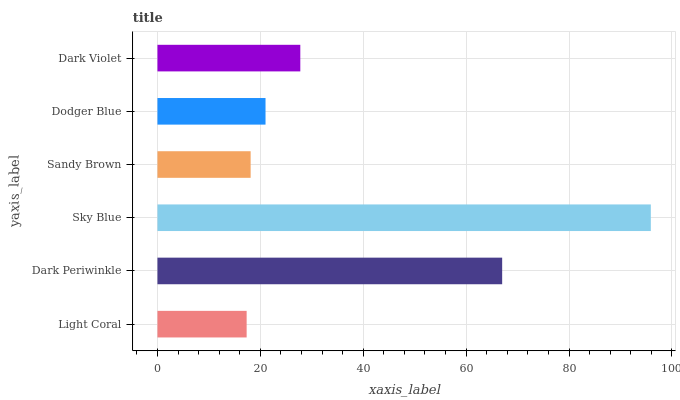Is Light Coral the minimum?
Answer yes or no. Yes. Is Sky Blue the maximum?
Answer yes or no. Yes. Is Dark Periwinkle the minimum?
Answer yes or no. No. Is Dark Periwinkle the maximum?
Answer yes or no. No. Is Dark Periwinkle greater than Light Coral?
Answer yes or no. Yes. Is Light Coral less than Dark Periwinkle?
Answer yes or no. Yes. Is Light Coral greater than Dark Periwinkle?
Answer yes or no. No. Is Dark Periwinkle less than Light Coral?
Answer yes or no. No. Is Dark Violet the high median?
Answer yes or no. Yes. Is Dodger Blue the low median?
Answer yes or no. Yes. Is Sky Blue the high median?
Answer yes or no. No. Is Light Coral the low median?
Answer yes or no. No. 